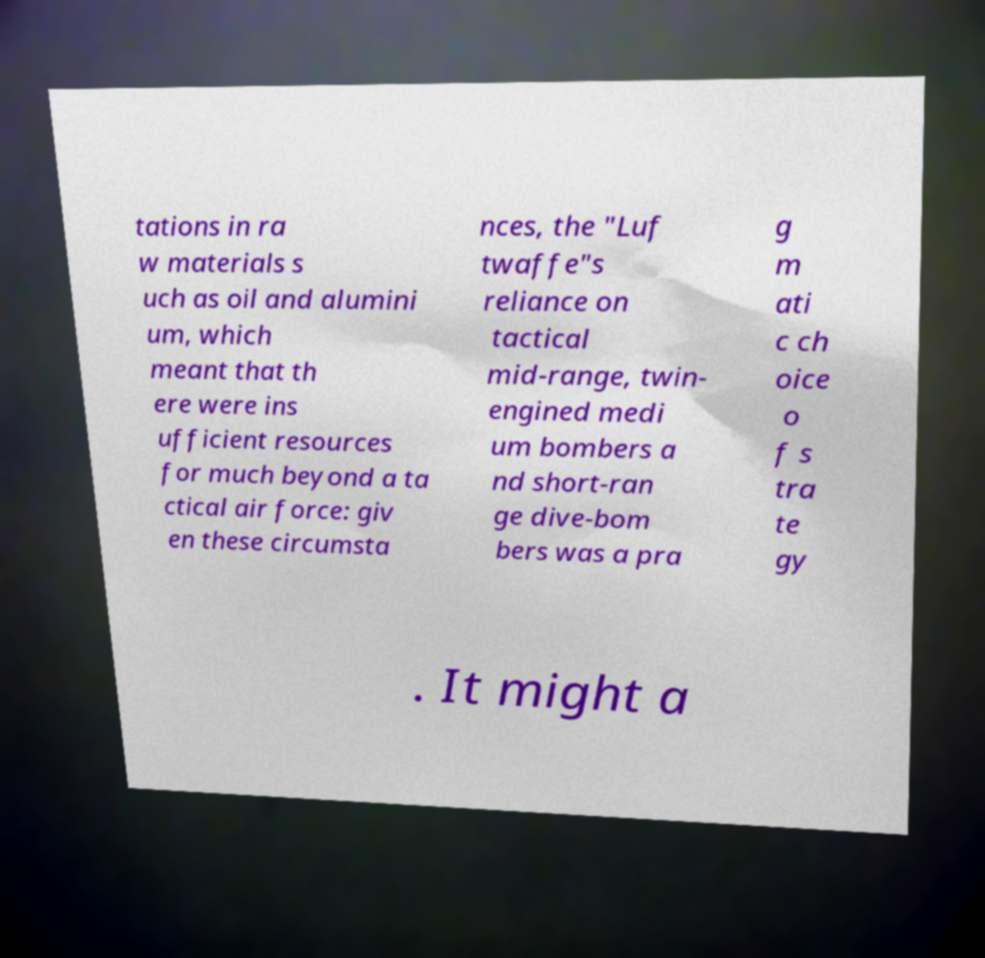What messages or text are displayed in this image? I need them in a readable, typed format. tations in ra w materials s uch as oil and alumini um, which meant that th ere were ins ufficient resources for much beyond a ta ctical air force: giv en these circumsta nces, the "Luf twaffe"s reliance on tactical mid-range, twin- engined medi um bombers a nd short-ran ge dive-bom bers was a pra g m ati c ch oice o f s tra te gy . It might a 